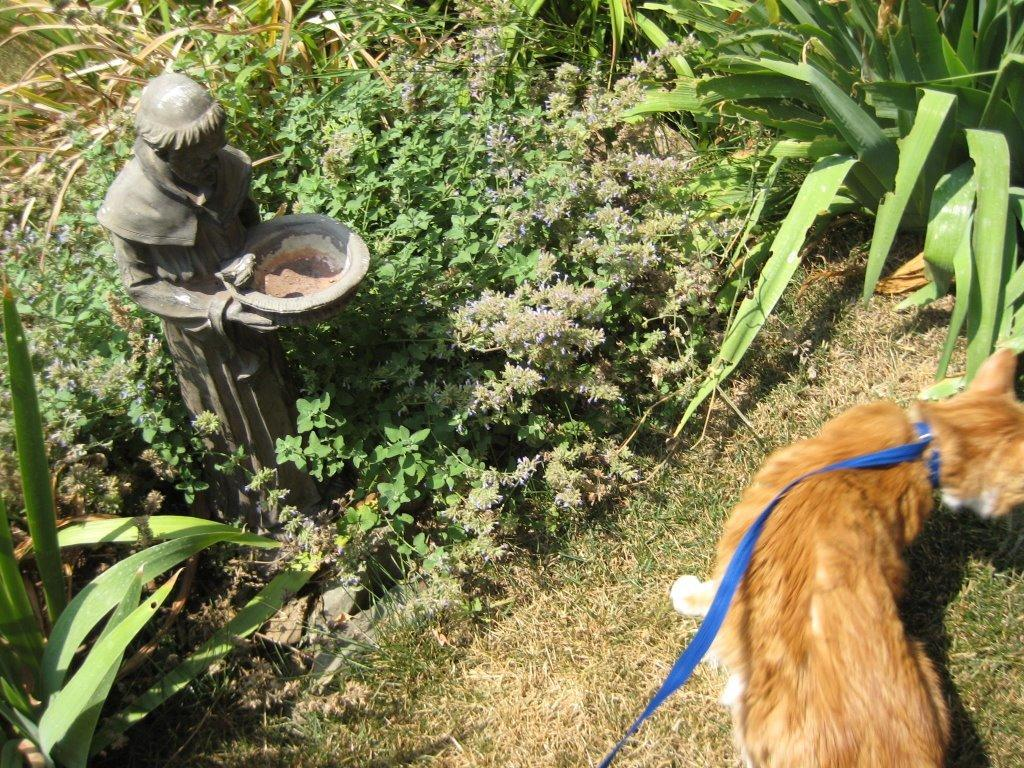What animal can be seen in the image? There is a dog in the image. Where is the dog positioned in the image? The dog is standing on the right side of the image. What is the dog's position relative to the ground? The dog is on the ground. What is attached to the dog's neck? There is a belt tied to the dog's neck. What other objects or structures are present in the image? There is a statue and plants in the image. What type of plough is the dog using in the image? There is no plough present in the image; it features a dog standing on the ground with a belt tied to its neck. Can you hear the dog crying in the image? The image is silent, so it is not possible to hear any sounds, including the dog crying. 